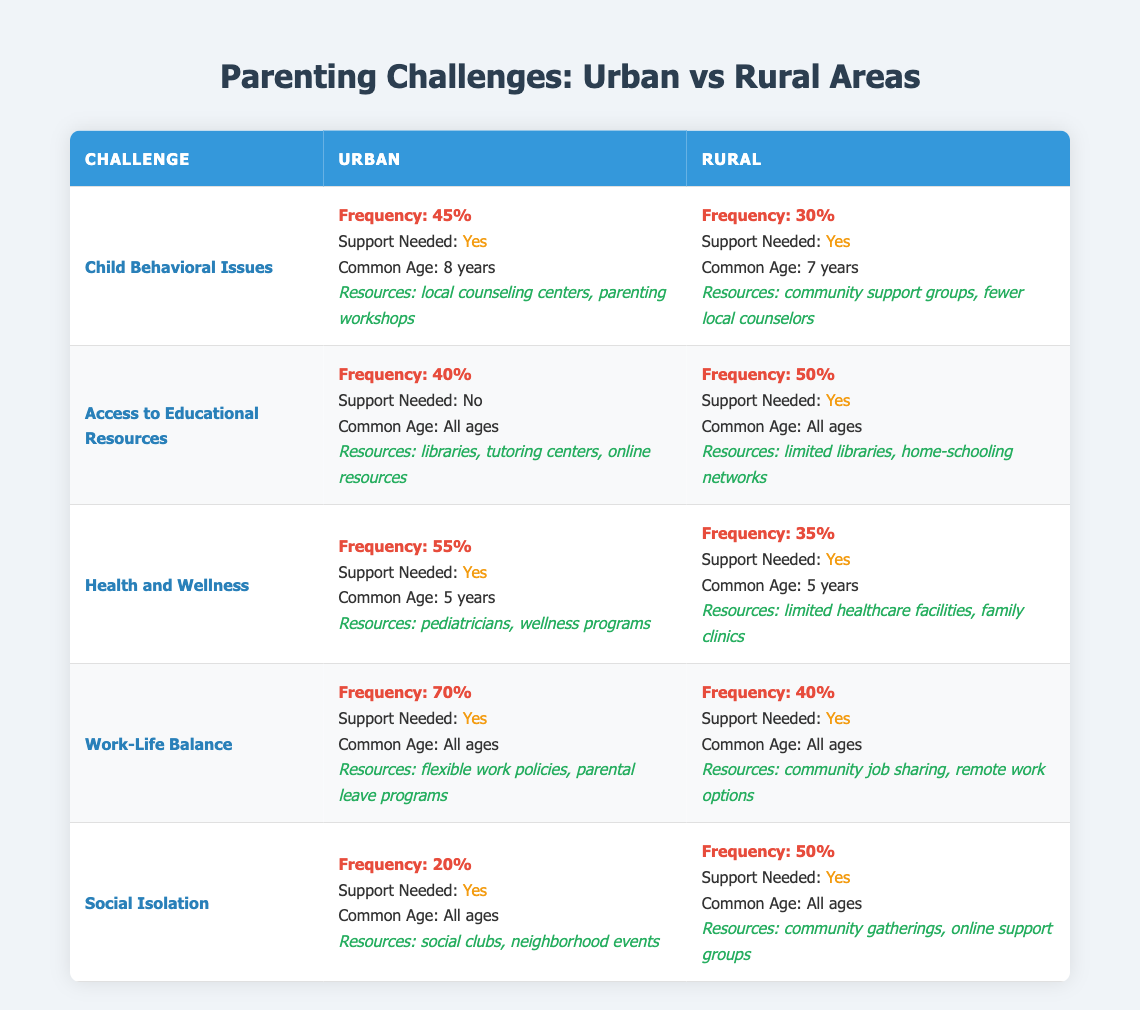What is the frequency of Child Behavioral Issues in urban areas? The table shows that the frequency of Child Behavioral Issues in urban areas is 45%.
Answer: 45% What resources are listed for Health and Wellness in rural areas? According to the table, the resources for Health and Wellness in rural areas are limited healthcare facilities and family clinics.
Answer: Limited healthcare facilities, family clinics Is support needed for Access to Educational Resources in urban areas? The table indicates that support is not needed for Access to Educational Resources in urban areas.
Answer: No Which challenge has the highest frequency in urban areas? By reviewing the frequencies listed in the urban section, Work-Life Balance has the highest frequency at 70%.
Answer: Work-Life Balance How does the frequency of Social Isolation in rural areas compare to urban areas? In rural areas, the frequency of Social Isolation is 50%, while in urban areas it is 20%. The difference is 50% - 20% = 30%.
Answer: Rural areas have a higher frequency by 30% What is the common age for Health and Wellness in both urban and rural areas? The common age for Health and Wellness is 5 years in both urban and rural areas, as stated in the table.
Answer: 5 years What is the sum of frequencies for Child Behavioral Issues and Work-Life Balance in urban areas? The frequencies are 45% for Child Behavioral Issues and 70% for Work-Life Balance. The sum is 45% + 70% = 115%.
Answer: 115% Is there a greater need for support in rural or urban areas for Social Isolation? The table shows that support is needed for Social Isolation in both areas, but the frequency is higher in rural areas (50% vs 20%). Therefore, while support is needed in both places, the issue is more prevalent in rural areas.
Answer: Rural areas Which challenge has no support needed in urban areas? Referring to the table, Access to Educational Resources is the challenge that states no support is needed in urban areas.
Answer: Access to Educational Resources What would you say is the general trend regarding access to resources for educational needs in urban versus rural areas? Based on the table, urban areas have more varied educational resources, including libraries and tutoring centers, whereas rural areas face challenges and support is often needed. This suggests that access is generally better in urban areas.
Answer: Urban areas have better access 